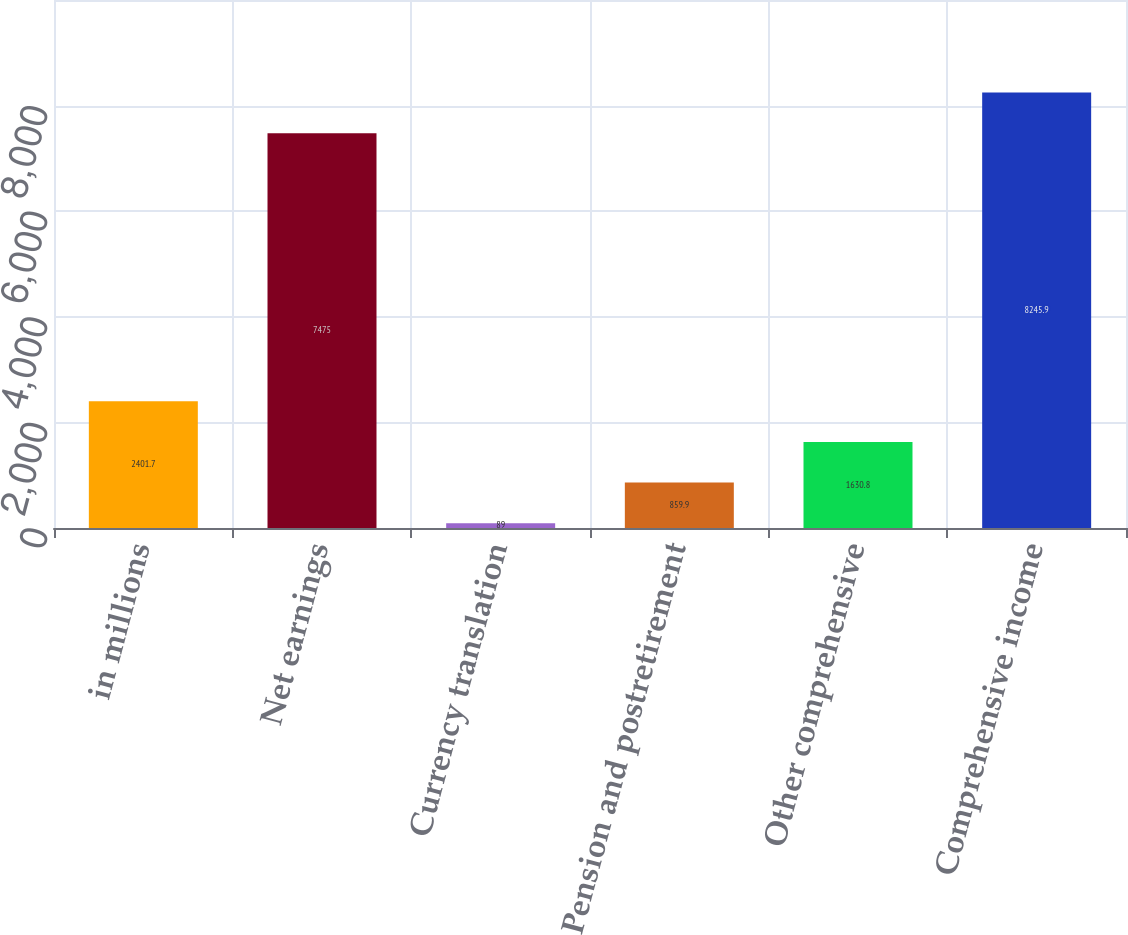Convert chart. <chart><loc_0><loc_0><loc_500><loc_500><bar_chart><fcel>in millions<fcel>Net earnings<fcel>Currency translation<fcel>Pension and postretirement<fcel>Other comprehensive<fcel>Comprehensive income<nl><fcel>2401.7<fcel>7475<fcel>89<fcel>859.9<fcel>1630.8<fcel>8245.9<nl></chart> 